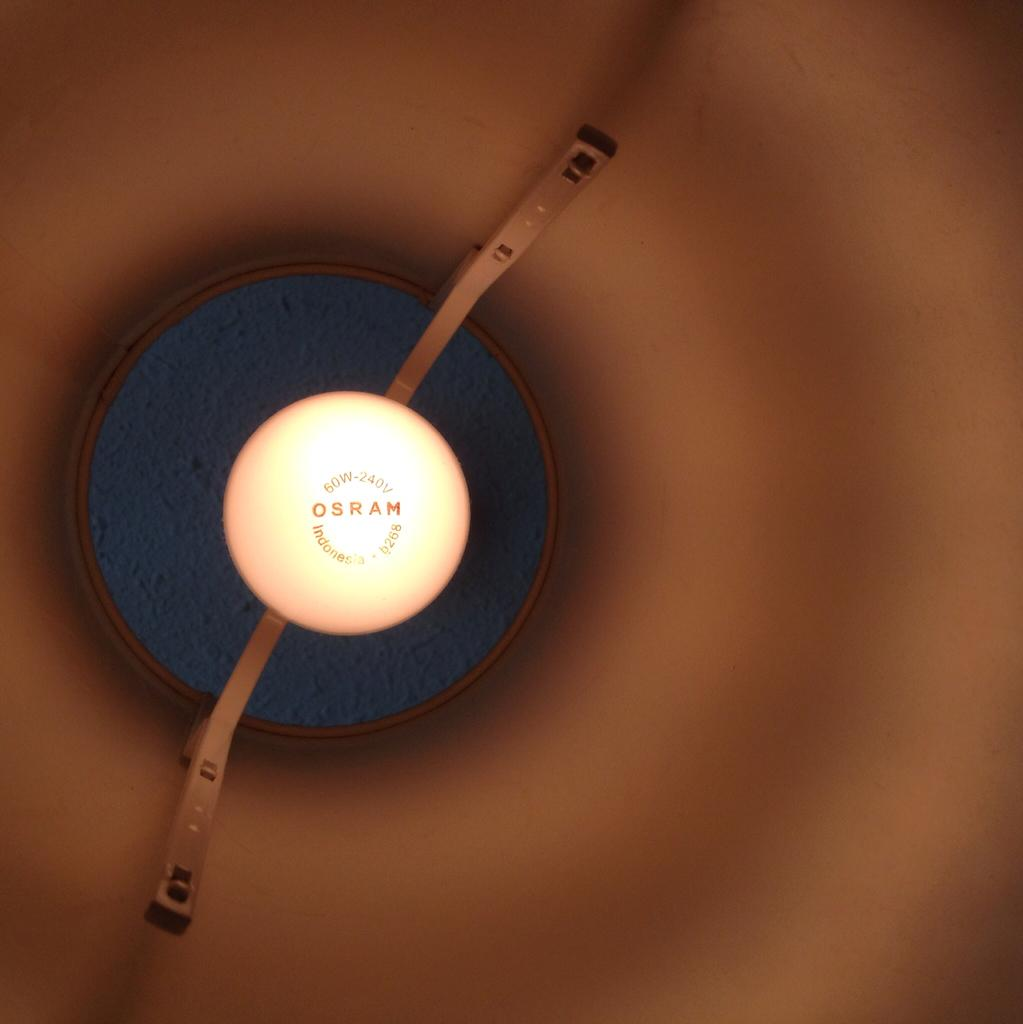What object is present in the image that provides light? There is a bulb in the image that provides light. Where is the bulb located in the image? The bulb is fixed to the ceiling in the image. What color is the bulb in the image? The bulb is yellow in color. What can be seen in the background of the image? There is a ceiling visible in the background of the image. What is the title of the painting on the canvas in the image? There is no painting or canvas present in the image. 